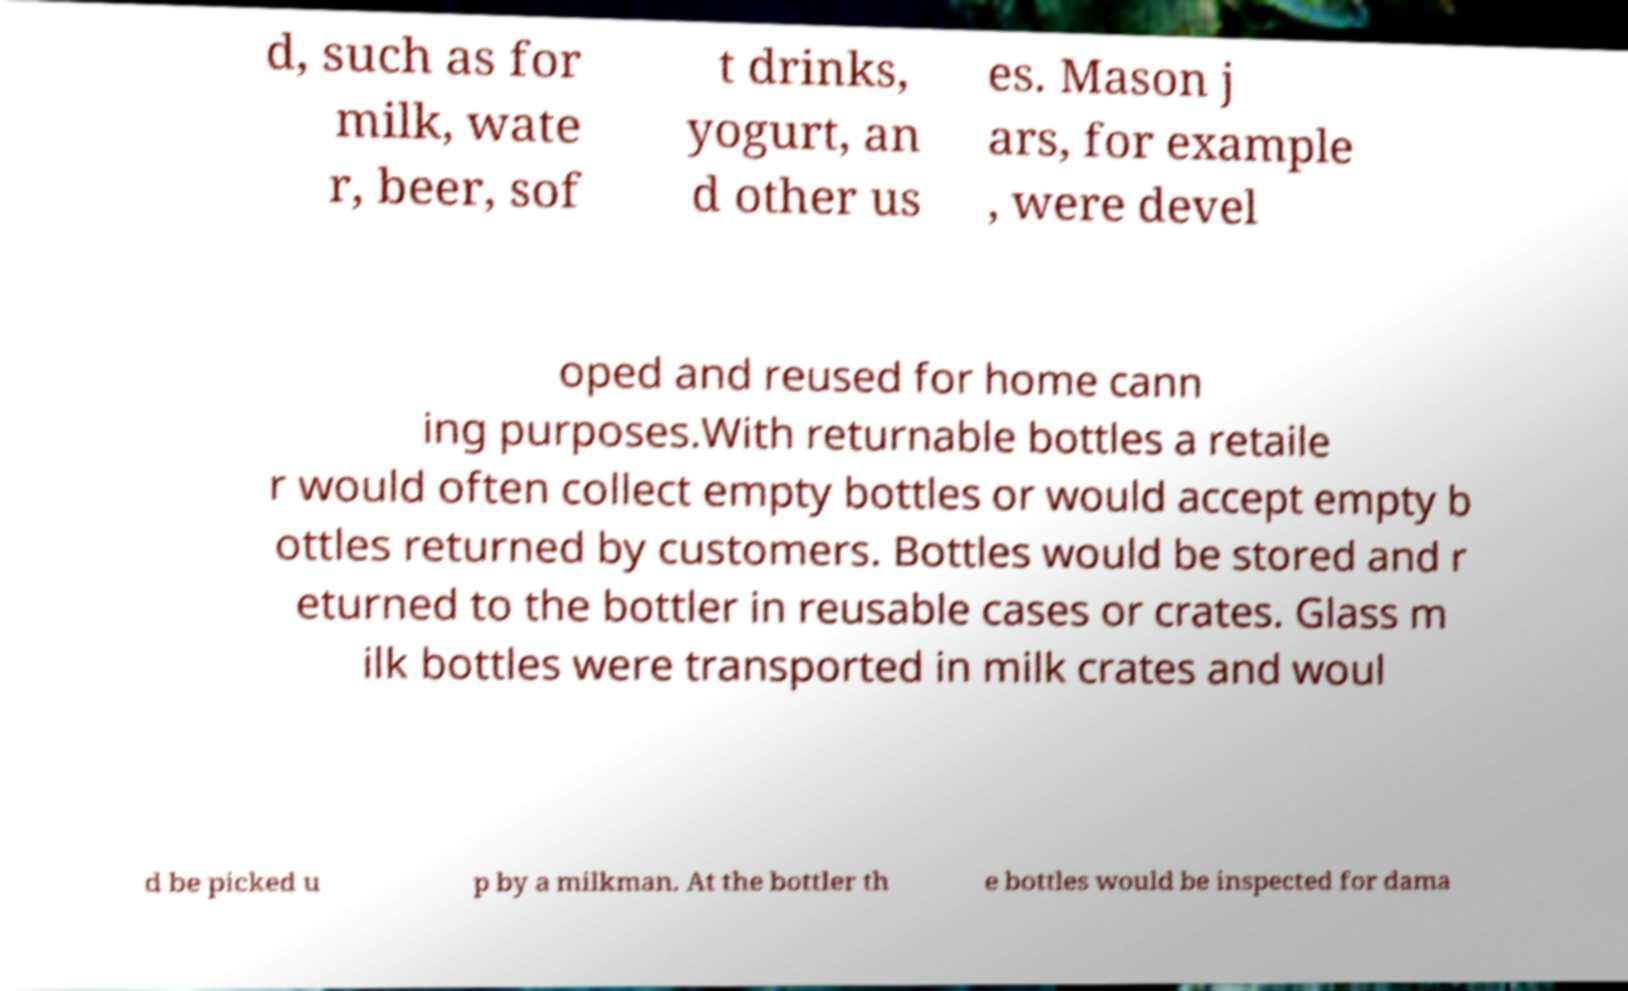What messages or text are displayed in this image? I need them in a readable, typed format. d, such as for milk, wate r, beer, sof t drinks, yogurt, an d other us es. Mason j ars, for example , were devel oped and reused for home cann ing purposes.With returnable bottles a retaile r would often collect empty bottles or would accept empty b ottles returned by customers. Bottles would be stored and r eturned to the bottler in reusable cases or crates. Glass m ilk bottles were transported in milk crates and woul d be picked u p by a milkman. At the bottler th e bottles would be inspected for dama 